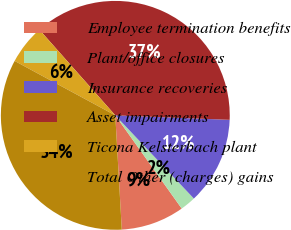Convert chart to OTSL. <chart><loc_0><loc_0><loc_500><loc_500><pie_chart><fcel>Employee termination benefits<fcel>Plant/office closures<fcel>Insurance recoveries<fcel>Asset impairments<fcel>Ticona Kelsterbach plant<fcel>Total Other (charges) gains<nl><fcel>8.95%<fcel>2.19%<fcel>12.33%<fcel>37.17%<fcel>5.57%<fcel>33.79%<nl></chart> 